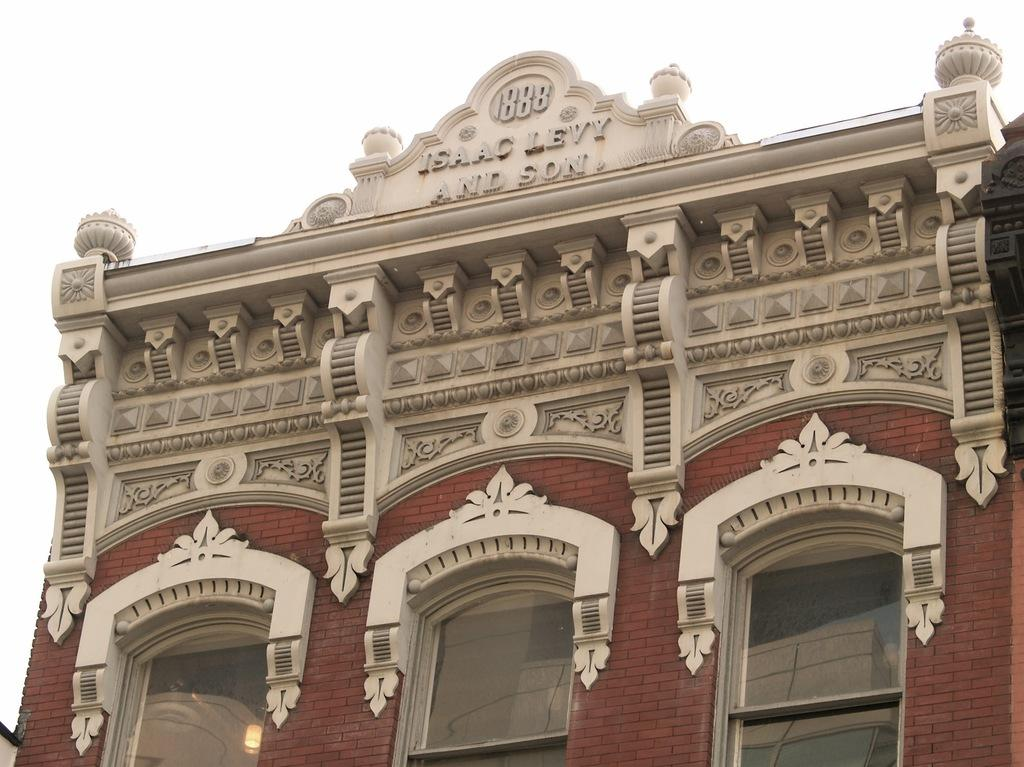What type of structure is shown in the image? The image is of a building. What feature can be seen on the building? The building has windows. Is there any decorative element on the building? Yes, there is a design carved on the wall of the building. What might the design represent? The design may represent a name on the building. Can you hear the straw coughing in the image? There is no straw or coughing sound present in the image; it features a building with a carved design on the wall. 